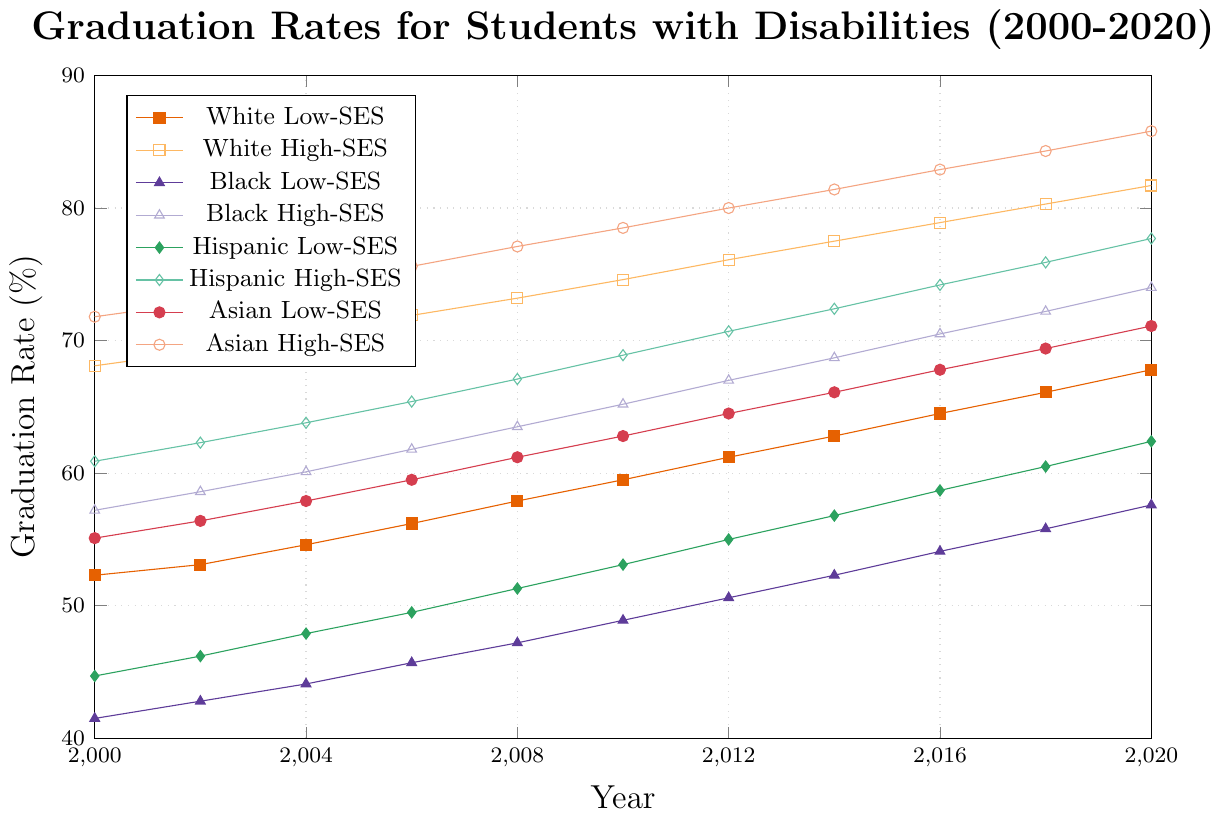What's the trend in graduation rates for White Low-SES students from 2000 to 2020? From the plot, we observe the line representing White Low-SES students. It begins at 52.3% in 2000 and ends at 67.8% in 2020, showing a steady upward trend over the two decades.
Answer: Increasing Which group had the highest graduation rate in 2020? By examining the lines on the plot for the year 2020, Asian High-SES students had the highest graduation rate, ending at 85.8%.
Answer: Asian High-SES students Compare the graduation rates of Black High-SES students and Hispanic Low-SES students in 2008. Visual inspection shows the lines for Black High-SES and Hispanic Low-SES intersect at differing heights in 2008, with Black High-SES at 63.5% and Hispanic Low-SES at 51.3%.
Answer: Black High-SES students How much did the graduation rate for Hispanic High-SES students increase from 2000 to 2020? The graph shows the line for Hispanic High-SES students starting at 60.9% in 2000 and rising to 77.7% in 2020. The increase is calculated as 77.7% - 60.9% = 16.8%.
Answer: 16.8% What's the average graduation rate for Black Low-SES students between 2000 and 2020? Adding the graduation rates for Black Low-SES (41.5, 42.8, 44.1, 45.7, 47.2, 48.9, 50.6, 52.3, 54.1, 55.8, 57.6) and dividing by 11 years: (41.5 + 42.8 + 44.1 + 45.7 + 47.2 + 48.9 + 50.6 + 52.3 + 54.1 + 55.8 + 57.6) / 11 ≈ 48.4.
Answer: 48.4% Which group showed the highest increase in graduation rates from 2000 to 2020? The differences for the groups are calculated as follows: White Low-SES: 67.8 - 52.3 = 15.5, White High-SES: 81.7 - 68.1 = 13.6, Black Low-SES: 57.6 - 41.5 = 16.1, Black High-SES: 74.0 - 57.2 = 16.8, Hispanic Low-SES: 62.4 - 44.7 = 17.7, Hispanic High-SES: 77.7 - 60.9 = 16.8, Asian Low-SES: 71.1 - 55.1 = 16.0, Asian High-SES: 85.8 - 71.8 = 14.0. Hispanic Low-SES students had the highest increase.
Answer: Hispanic Low-SES students Compare the graduation rate gaps between Low-SES and High-SES students within the same racial group in 2020. Calculating the differences: White: 81.7 - 67.8 = 13.9, Black: 74.0 - 57.6 = 16.4, Hispanic: 77.7 - 62.4 = 15.3, Asian: 85.8 - 71.1 = 14.7. Observing the larger gap within the Black students.
Answer: Black students How did the graduation rates for Asian Low-SES students change between 2008 and 2018? The graph shows the rates: 61.2% in 2008 and 69.4% in 2018. The difference is 69.4% - 61.2% = 8.2%.
Answer: 8.2% Identify which group had the least improvement in graduation rates over the two decades. Calculating improvements: White Low-SES: 15.5, White High-SES: 13.6, Black Low-SES: 16.1, Black High-SES: 16.8, Hispanic Low-SES: 17.7, Hispanic High-SES: 16.8, Asian Low-SES: 16.0, Asian High-SES: 14.0. White High-SES had the smallest increase.
Answer: White High-SES students 